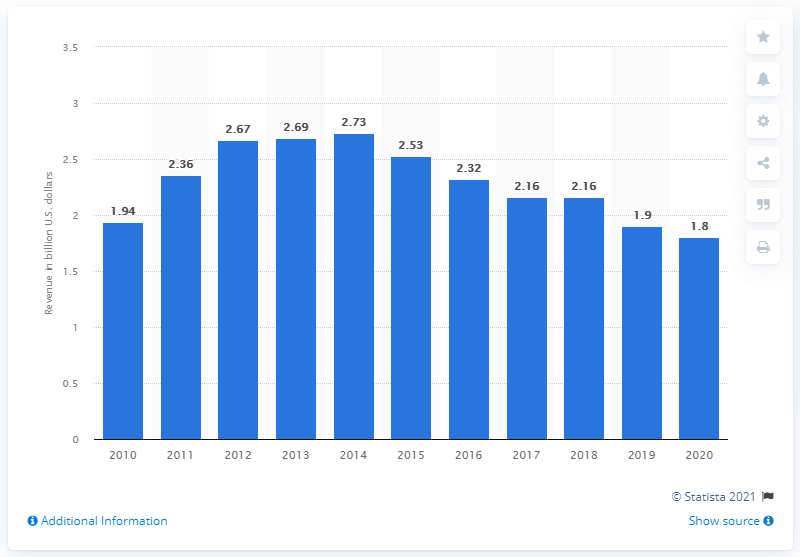Mention a couple of crucial points in this snapshot. In 2020, Teradata reported revenues of 1.8 billion dollars. In 2020, Teradata reported a revenue of 1.8 billion USD. 